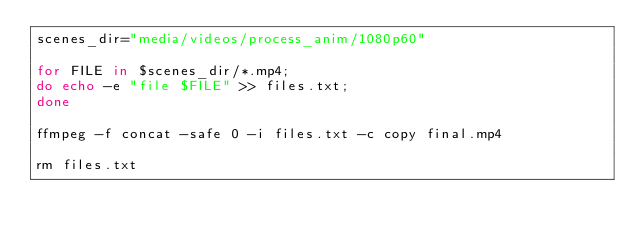<code> <loc_0><loc_0><loc_500><loc_500><_Bash_>scenes_dir="media/videos/process_anim/1080p60"

for FILE in $scenes_dir/*.mp4; 
do echo -e "file $FILE" >> files.txt;
done

ffmpeg -f concat -safe 0 -i files.txt -c copy final.mp4

rm files.txt
</code> 